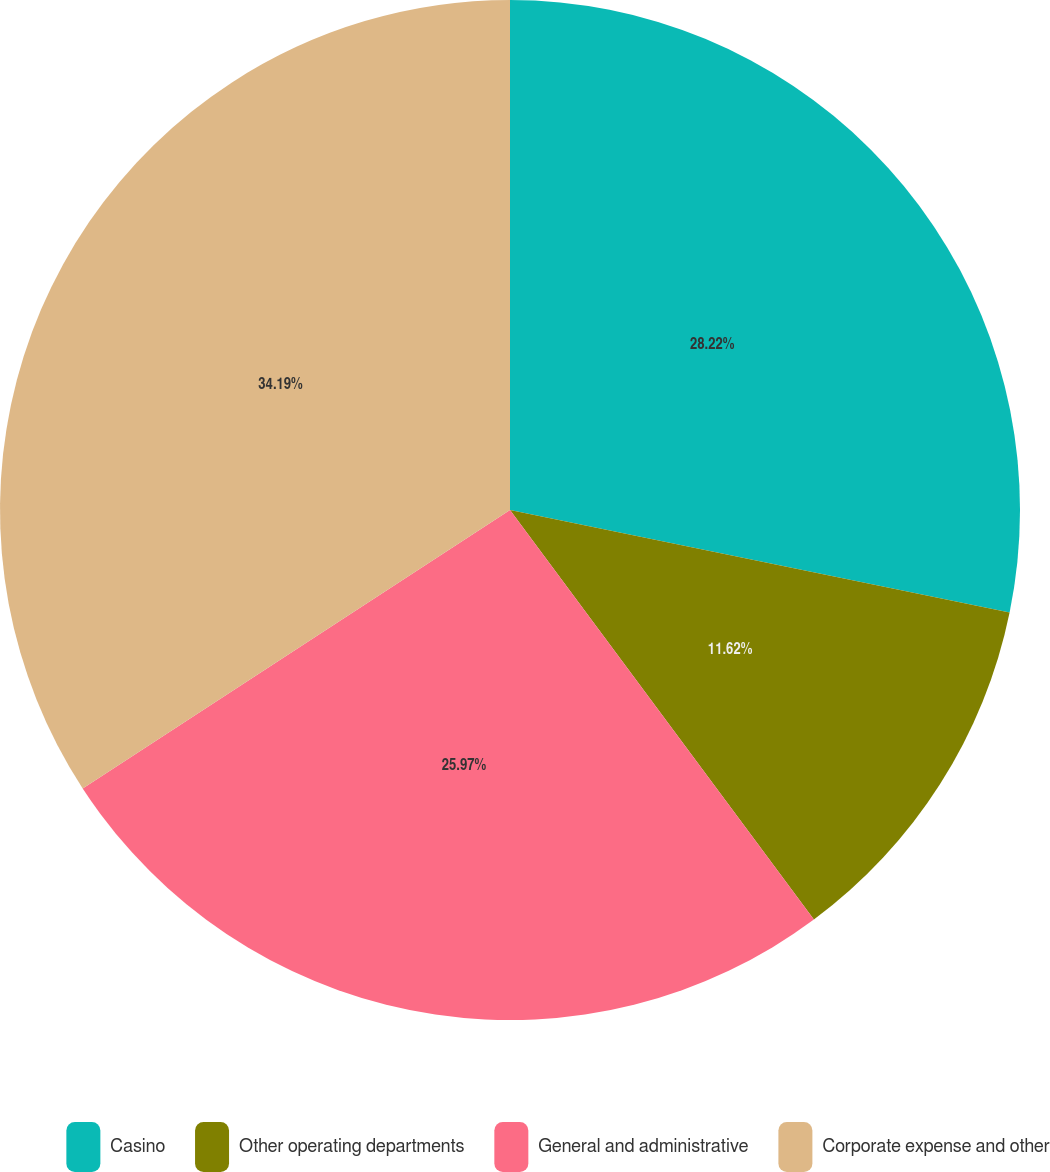<chart> <loc_0><loc_0><loc_500><loc_500><pie_chart><fcel>Casino<fcel>Other operating departments<fcel>General and administrative<fcel>Corporate expense and other<nl><fcel>28.22%<fcel>11.62%<fcel>25.97%<fcel>34.19%<nl></chart> 